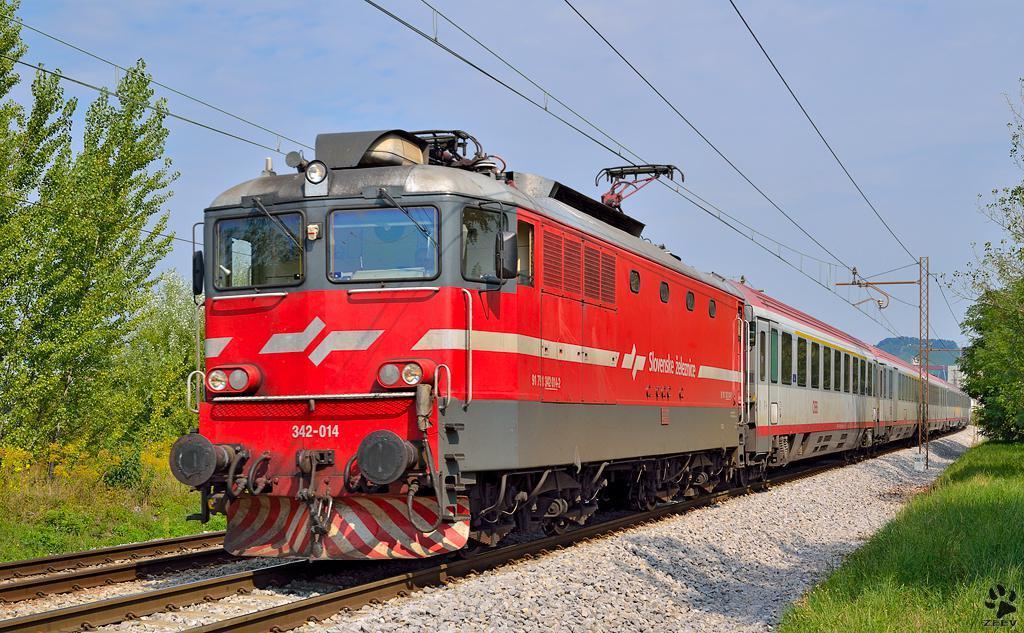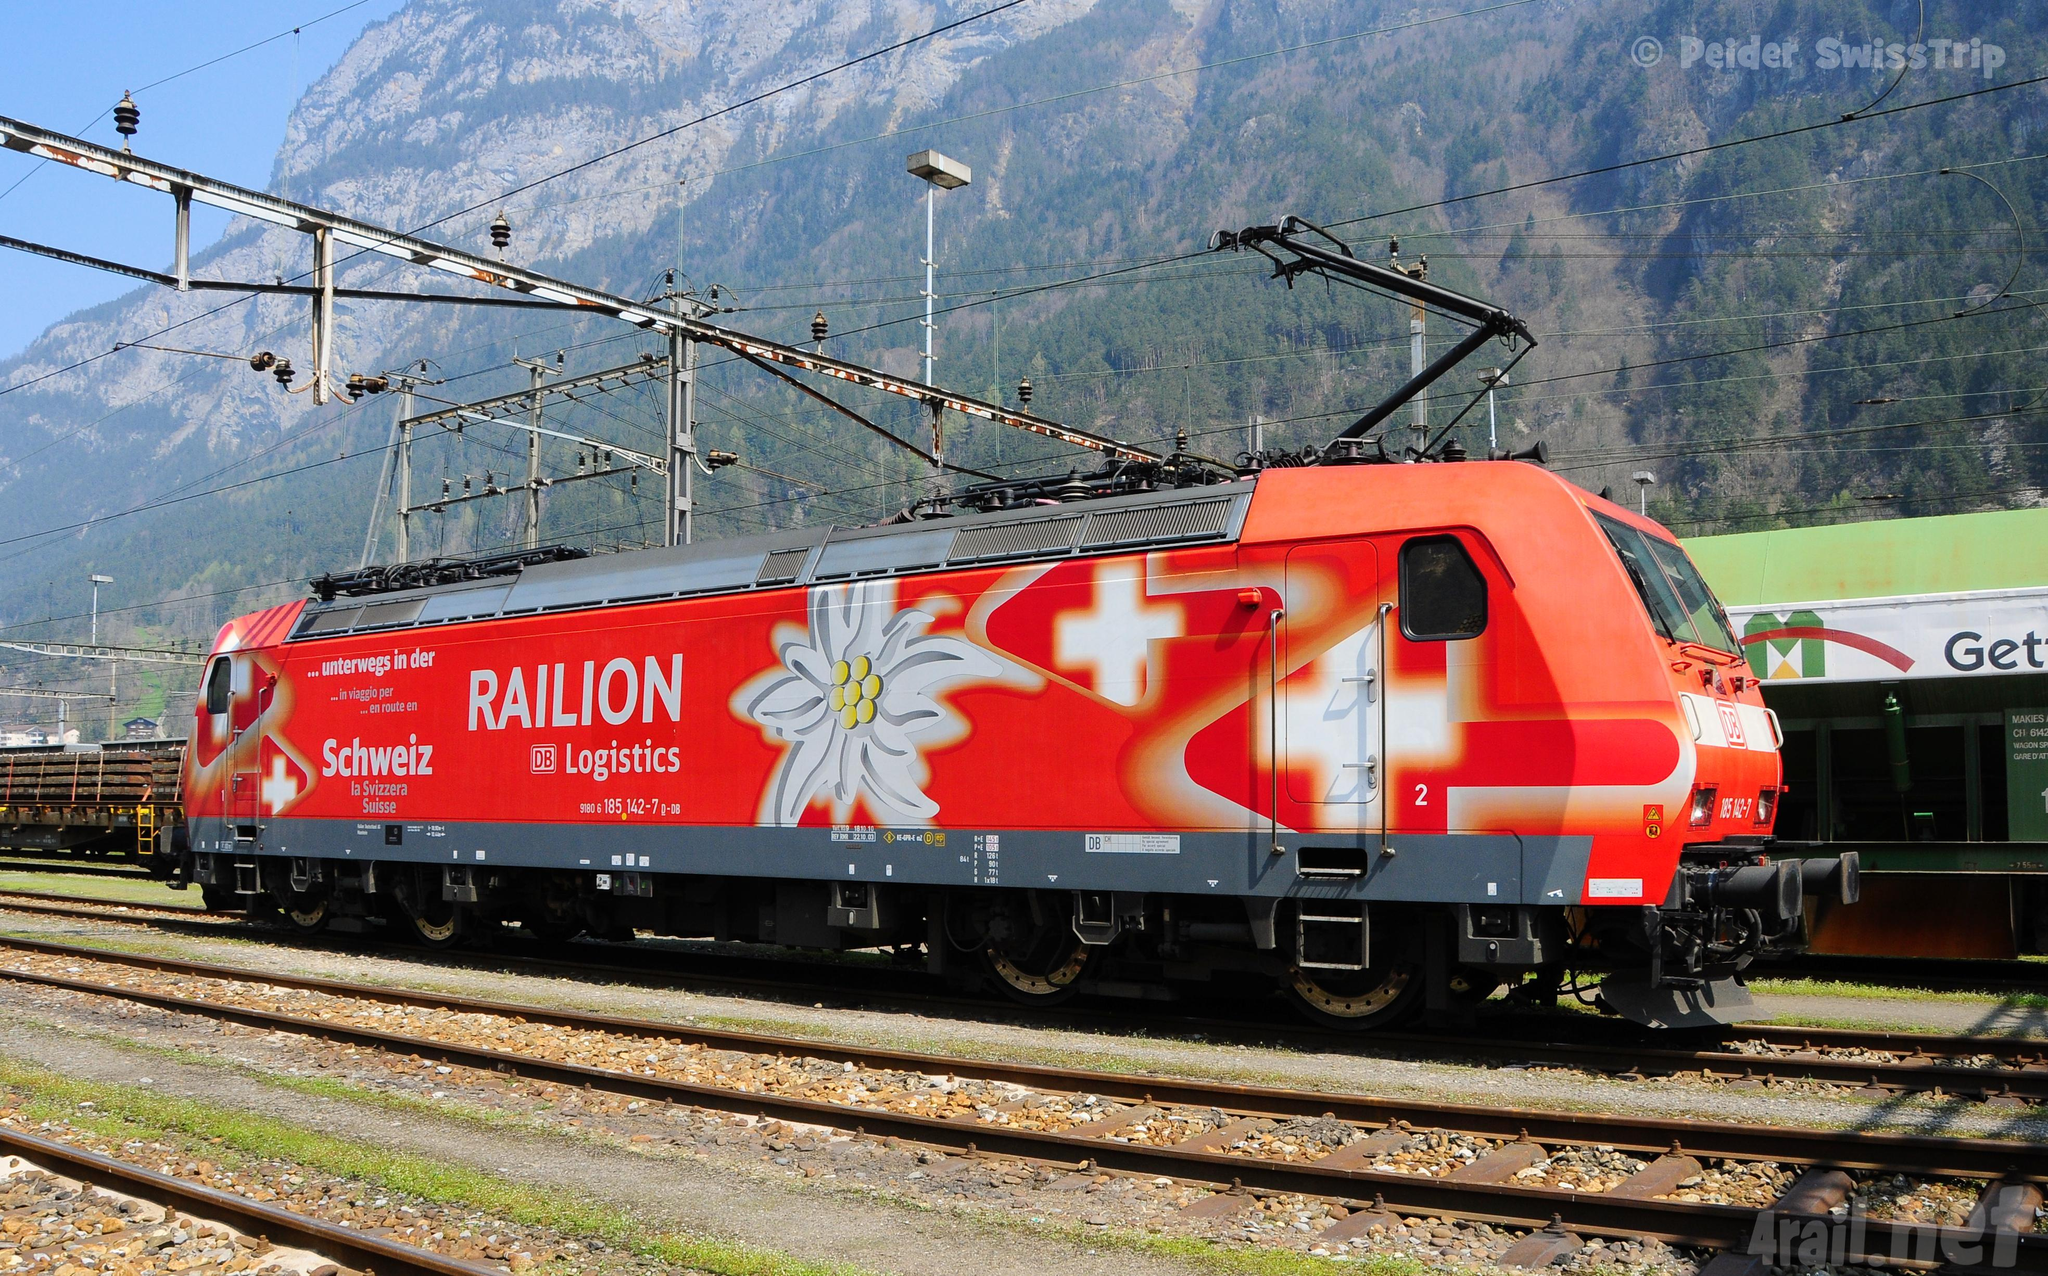The first image is the image on the left, the second image is the image on the right. For the images shown, is this caption "All the trains are angled in the same general direction." true? Answer yes or no. No. 